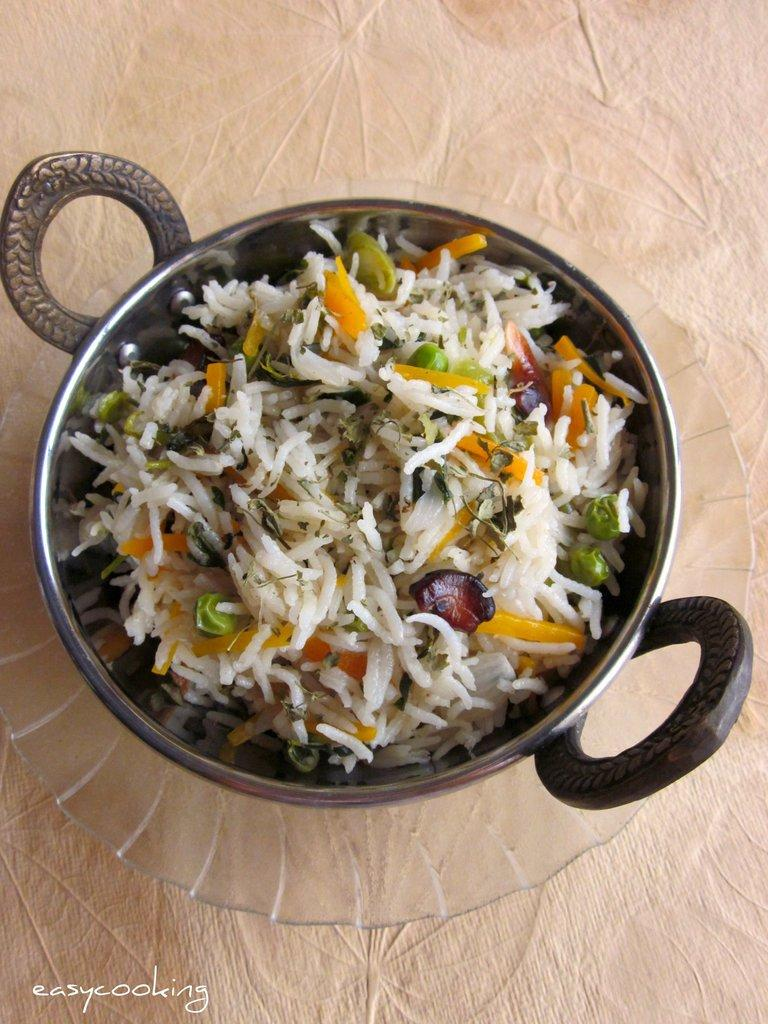What type of food can be seen in the pan in the image? There is fried rice in the pan in the image. How is the pan containing the fried rice positioned in the image? The pan is placed in a glass bowl. Where is the glass bowl with the pan located in the image? The glass bowl with the pan is placed on a table. How far away is the wrench from the pan in the image? There is no wrench present in the image, so it cannot be determined how far away it might be from the pan. 